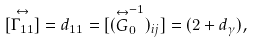<formula> <loc_0><loc_0><loc_500><loc_500>[ \stackrel { \leftrightarrow } { \Gamma _ { 1 1 } } ] = d _ { 1 1 } = [ ( \stackrel { \leftrightarrow } { G } ^ { - 1 } _ { 0 } ) _ { i j } ] = ( 2 + d _ { \gamma } ) ,</formula> 